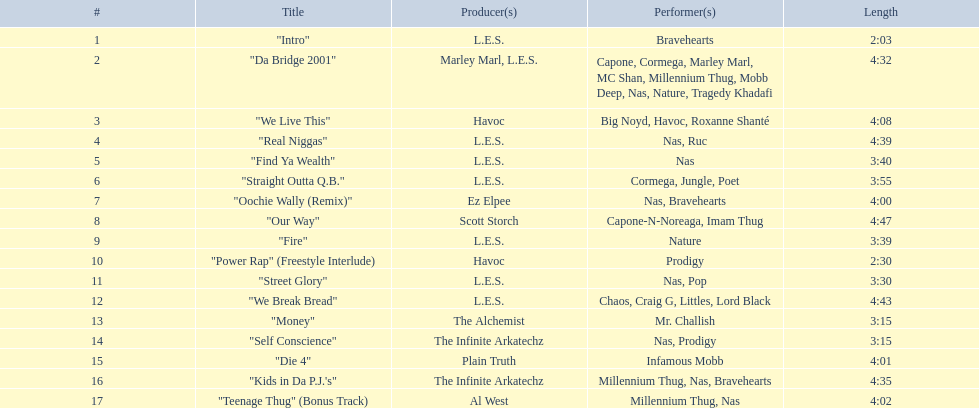What are the track times on the nas & ill will records presents qb's finest album? 2:03, 4:32, 4:08, 4:39, 3:40, 3:55, 4:00, 4:47, 3:39, 2:30, 3:30, 4:43, 3:15, 3:15, 4:01, 4:35, 4:02. Of those which is the longest? 4:47. 